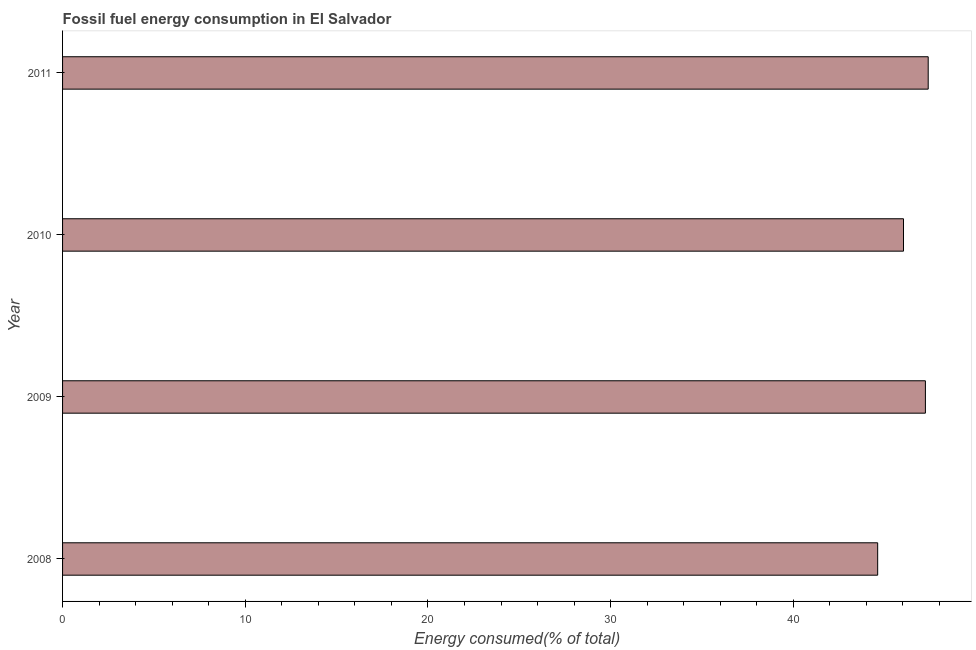Does the graph contain any zero values?
Your answer should be compact. No. Does the graph contain grids?
Provide a short and direct response. No. What is the title of the graph?
Give a very brief answer. Fossil fuel energy consumption in El Salvador. What is the label or title of the X-axis?
Make the answer very short. Energy consumed(% of total). What is the fossil fuel energy consumption in 2011?
Offer a very short reply. 47.38. Across all years, what is the maximum fossil fuel energy consumption?
Ensure brevity in your answer.  47.38. Across all years, what is the minimum fossil fuel energy consumption?
Offer a terse response. 44.62. What is the sum of the fossil fuel energy consumption?
Keep it short and to the point. 185.26. What is the difference between the fossil fuel energy consumption in 2008 and 2010?
Your answer should be very brief. -1.41. What is the average fossil fuel energy consumption per year?
Make the answer very short. 46.31. What is the median fossil fuel energy consumption?
Provide a short and direct response. 46.63. Is the difference between the fossil fuel energy consumption in 2008 and 2010 greater than the difference between any two years?
Make the answer very short. No. What is the difference between the highest and the second highest fossil fuel energy consumption?
Offer a terse response. 0.15. Is the sum of the fossil fuel energy consumption in 2009 and 2010 greater than the maximum fossil fuel energy consumption across all years?
Keep it short and to the point. Yes. What is the difference between the highest and the lowest fossil fuel energy consumption?
Provide a succinct answer. 2.77. In how many years, is the fossil fuel energy consumption greater than the average fossil fuel energy consumption taken over all years?
Your response must be concise. 2. What is the difference between two consecutive major ticks on the X-axis?
Ensure brevity in your answer.  10. Are the values on the major ticks of X-axis written in scientific E-notation?
Provide a succinct answer. No. What is the Energy consumed(% of total) of 2008?
Ensure brevity in your answer.  44.62. What is the Energy consumed(% of total) of 2009?
Your response must be concise. 47.23. What is the Energy consumed(% of total) in 2010?
Offer a very short reply. 46.03. What is the Energy consumed(% of total) of 2011?
Your response must be concise. 47.38. What is the difference between the Energy consumed(% of total) in 2008 and 2009?
Offer a very short reply. -2.61. What is the difference between the Energy consumed(% of total) in 2008 and 2010?
Your response must be concise. -1.41. What is the difference between the Energy consumed(% of total) in 2008 and 2011?
Ensure brevity in your answer.  -2.77. What is the difference between the Energy consumed(% of total) in 2009 and 2010?
Make the answer very short. 1.2. What is the difference between the Energy consumed(% of total) in 2009 and 2011?
Provide a short and direct response. -0.15. What is the difference between the Energy consumed(% of total) in 2010 and 2011?
Ensure brevity in your answer.  -1.35. What is the ratio of the Energy consumed(% of total) in 2008 to that in 2009?
Ensure brevity in your answer.  0.94. What is the ratio of the Energy consumed(% of total) in 2008 to that in 2010?
Provide a short and direct response. 0.97. What is the ratio of the Energy consumed(% of total) in 2008 to that in 2011?
Ensure brevity in your answer.  0.94. What is the ratio of the Energy consumed(% of total) in 2009 to that in 2010?
Give a very brief answer. 1.03. 